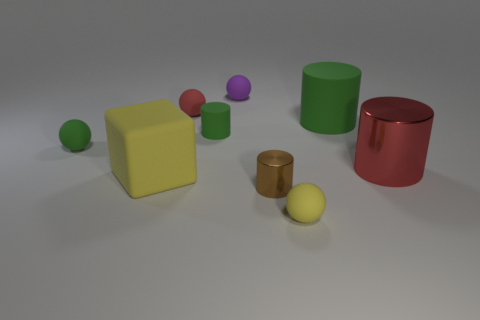What number of large cylinders are the same material as the tiny green cylinder?
Offer a very short reply. 1. There is a red object left of the big metal object; what is its shape?
Keep it short and to the point. Sphere. Is the big yellow cube made of the same material as the green thing that is on the right side of the yellow sphere?
Your answer should be very brief. Yes. Is there a tiny yellow matte sphere?
Your answer should be very brief. Yes. Are there any green matte spheres to the left of the small sphere that is in front of the red thing that is in front of the small red thing?
Your response must be concise. Yes. What number of tiny objects are red shiny things or cylinders?
Your response must be concise. 2. What color is the metal object that is the same size as the purple matte sphere?
Make the answer very short. Brown. What number of objects are in front of the small brown cylinder?
Make the answer very short. 1. Are there any objects that have the same material as the large red cylinder?
Ensure brevity in your answer.  Yes. What is the shape of the tiny object that is the same color as the large matte cube?
Offer a terse response. Sphere. 